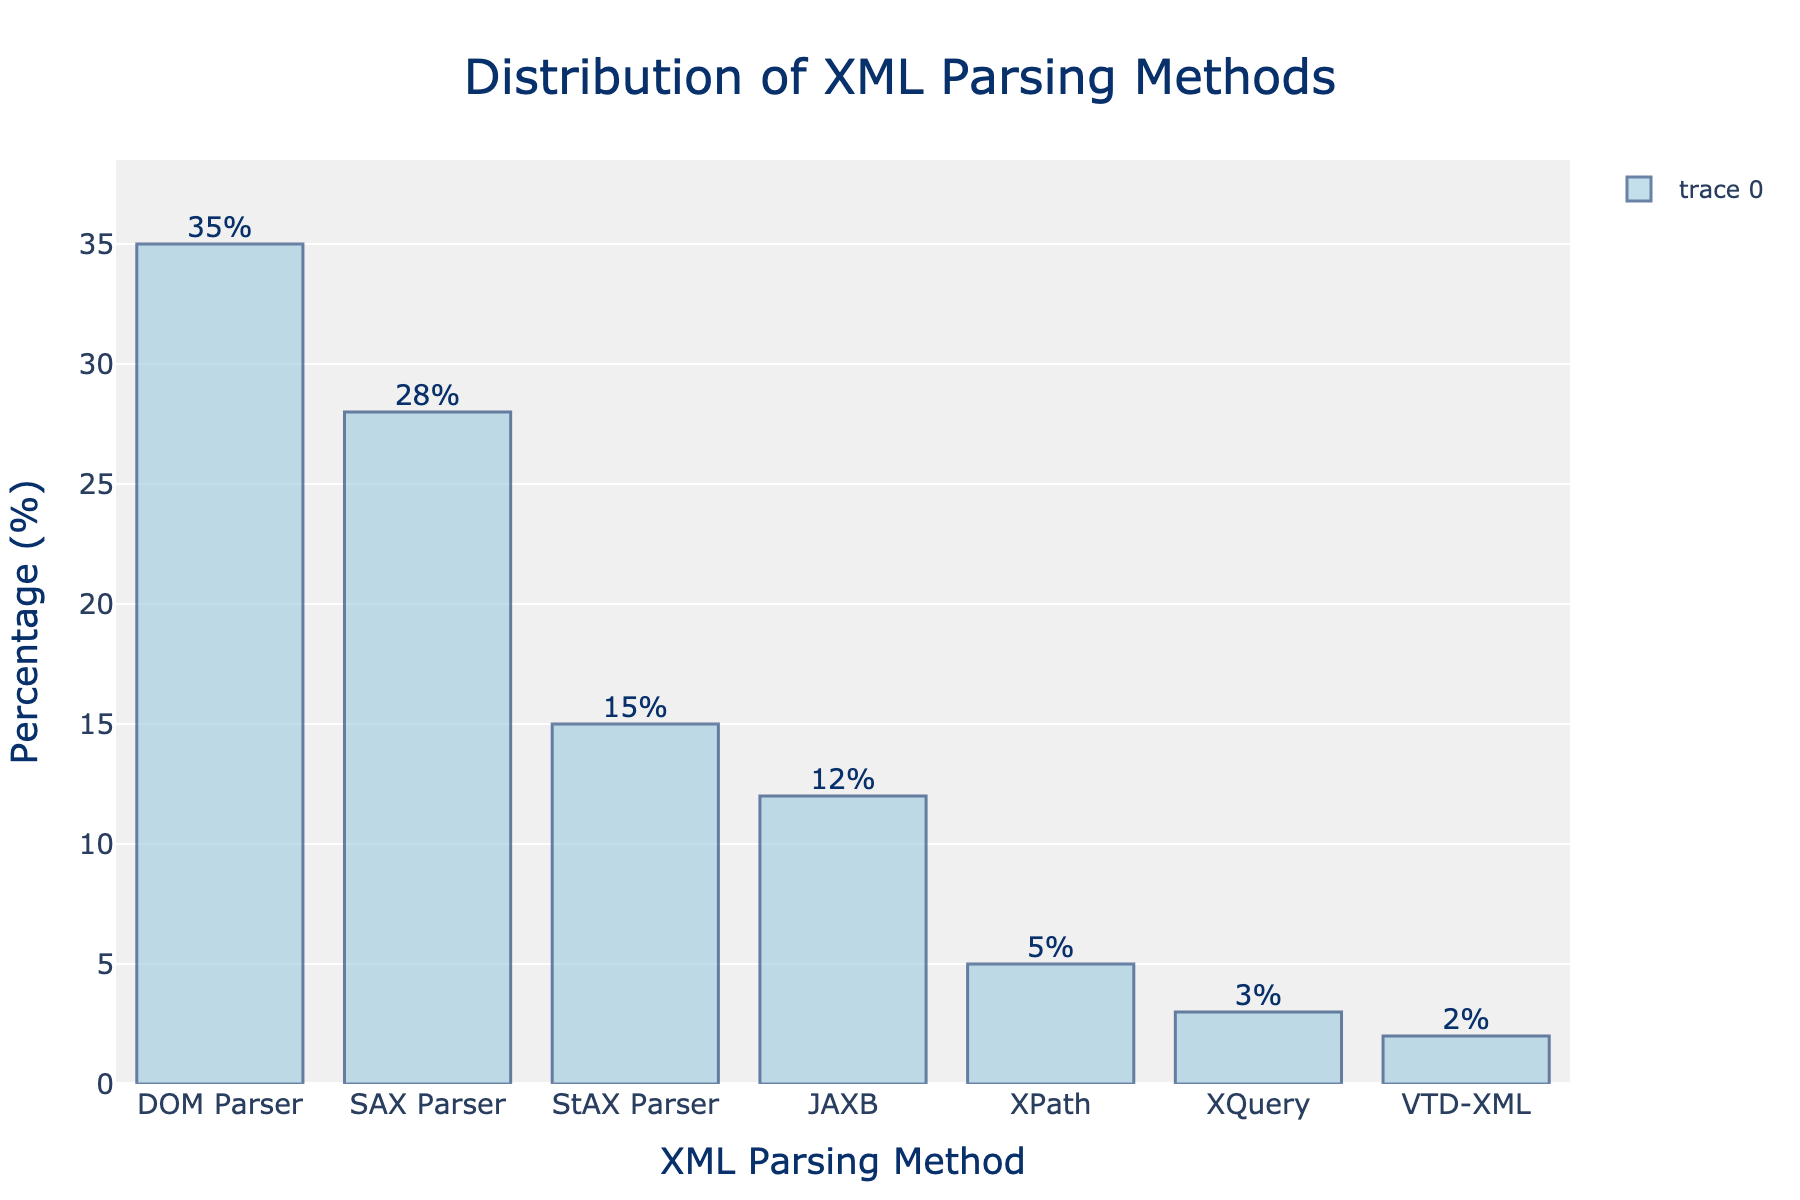What is the most commonly used XML parsing method in popular software libraries? The tallest bar on the chart represents the DOM Parser with 35%, indicating it is the most commonly used.
Answer: DOM Parser What is the combined percentage of SAX Parser and JAXB usage? The SAX Parser has a percentage of 28% and JAXB has 12%. Adding these together gives 28% + 12% = 40%.
Answer: 40% Which XML parsing method is the least commonly used? The shortest bar on the chart represents VTD-XML with 2%, making it the least commonly used.
Answer: VTD-XML How much more popular is the DOM Parser compared to the StAX Parser? The percentage for DOM Parser is 35% and for StAX Parser is 15%. Subtracting these gives 35% - 15% = 20%.
Answer: 20% What is the average percentage of usage among all XML parsing methods? Adding all the percentages: 35 + 28 + 15 + 12 + 5 + 3 + 2 = 100. Dividing by the number of methods (7) gives 100 / 7 ≈ 14.29%.
Answer: 14.29% Which XML parsing methods have a usage percentage greater than 10%? Referring to the chart, the methods with percentages greater than 10% are DOM Parser, SAX Parser, StAX Parser, and JAXB.
Answer: DOM Parser, SAX Parser, StAX Parser, JAXB By how much does JAXB exceed the usage of XQuery? JAXB has a percentage of 12%, and XQuery has 3%. Subtracting these gives 12% - 3% = 9%.
Answer: 9% What is the total percentage for methods with usage 5% or less? Adding the percentages for XPath (5%), XQuery (3%), and VTD-XML (2%) gives 5 + 3 + 2 = 10%.
Answer: 10% Is the combined percentage usage of StAX Parser and XPath greater than that of SAX Parser? StAX Parser has 15% and XPath has 5%. Their combined percentage is 15% + 5% = 20%, which is less than SAX Parser's 28%.
Answer: No How many XML parsing methods have a usage percentage greater than 20%? Referring to the chart, only two methods (DOM Parser at 35% and SAX Parser at 28%) have usage percentages greater than 20%.
Answer: 2 